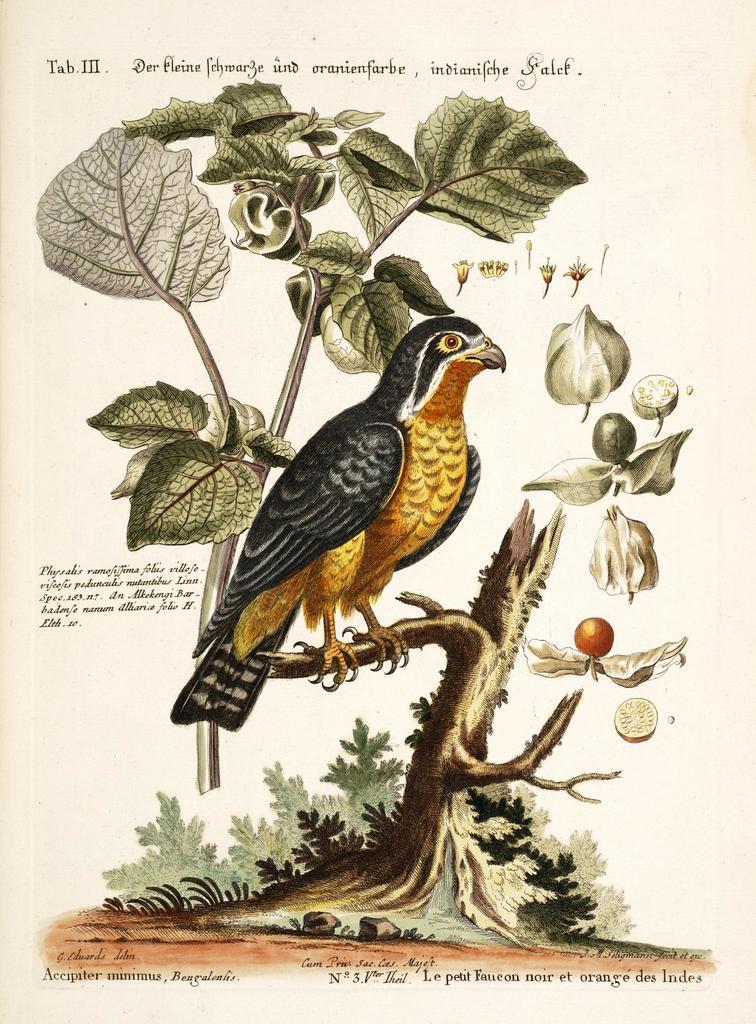Describe this image in one or two sentences. In this picture I can see a paper with words, numbers and there is a photo of a tree trunk, plant, fruits, leaves and a bird on the paper. 